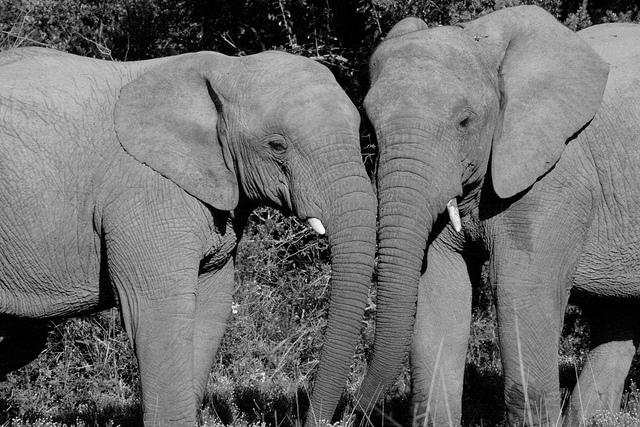How many elephants are there?
Short answer required. 2. Have you ever touched an elegant?
Write a very short answer. No. What kind of filter is used?
Keep it brief. Black and white. Are the animals fighting?
Quick response, please. No. 